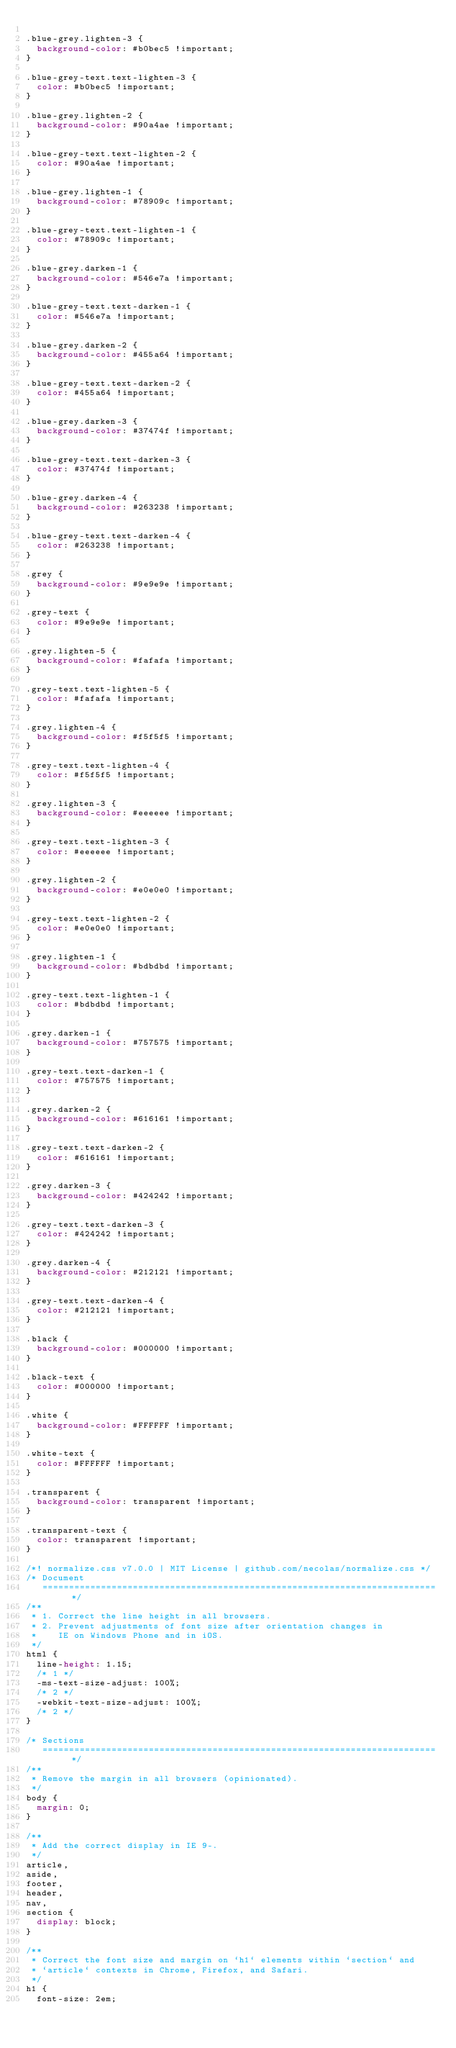<code> <loc_0><loc_0><loc_500><loc_500><_CSS_>
.blue-grey.lighten-3 {
  background-color: #b0bec5 !important;
}

.blue-grey-text.text-lighten-3 {
  color: #b0bec5 !important;
}

.blue-grey.lighten-2 {
  background-color: #90a4ae !important;
}

.blue-grey-text.text-lighten-2 {
  color: #90a4ae !important;
}

.blue-grey.lighten-1 {
  background-color: #78909c !important;
}

.blue-grey-text.text-lighten-1 {
  color: #78909c !important;
}

.blue-grey.darken-1 {
  background-color: #546e7a !important;
}

.blue-grey-text.text-darken-1 {
  color: #546e7a !important;
}

.blue-grey.darken-2 {
  background-color: #455a64 !important;
}

.blue-grey-text.text-darken-2 {
  color: #455a64 !important;
}

.blue-grey.darken-3 {
  background-color: #37474f !important;
}

.blue-grey-text.text-darken-3 {
  color: #37474f !important;
}

.blue-grey.darken-4 {
  background-color: #263238 !important;
}

.blue-grey-text.text-darken-4 {
  color: #263238 !important;
}

.grey {
  background-color: #9e9e9e !important;
}

.grey-text {
  color: #9e9e9e !important;
}

.grey.lighten-5 {
  background-color: #fafafa !important;
}

.grey-text.text-lighten-5 {
  color: #fafafa !important;
}

.grey.lighten-4 {
  background-color: #f5f5f5 !important;
}

.grey-text.text-lighten-4 {
  color: #f5f5f5 !important;
}

.grey.lighten-3 {
  background-color: #eeeeee !important;
}

.grey-text.text-lighten-3 {
  color: #eeeeee !important;
}

.grey.lighten-2 {
  background-color: #e0e0e0 !important;
}

.grey-text.text-lighten-2 {
  color: #e0e0e0 !important;
}

.grey.lighten-1 {
  background-color: #bdbdbd !important;
}

.grey-text.text-lighten-1 {
  color: #bdbdbd !important;
}

.grey.darken-1 {
  background-color: #757575 !important;
}

.grey-text.text-darken-1 {
  color: #757575 !important;
}

.grey.darken-2 {
  background-color: #616161 !important;
}

.grey-text.text-darken-2 {
  color: #616161 !important;
}

.grey.darken-3 {
  background-color: #424242 !important;
}

.grey-text.text-darken-3 {
  color: #424242 !important;
}

.grey.darken-4 {
  background-color: #212121 !important;
}

.grey-text.text-darken-4 {
  color: #212121 !important;
}

.black {
  background-color: #000000 !important;
}

.black-text {
  color: #000000 !important;
}

.white {
  background-color: #FFFFFF !important;
}

.white-text {
  color: #FFFFFF !important;
}

.transparent {
  background-color: transparent !important;
}

.transparent-text {
  color: transparent !important;
}

/*! normalize.css v7.0.0 | MIT License | github.com/necolas/normalize.css */
/* Document
   ========================================================================== */
/**
 * 1. Correct the line height in all browsers.
 * 2. Prevent adjustments of font size after orientation changes in
 *    IE on Windows Phone and in iOS.
 */
html {
  line-height: 1.15;
  /* 1 */
  -ms-text-size-adjust: 100%;
  /* 2 */
  -webkit-text-size-adjust: 100%;
  /* 2 */
}

/* Sections
   ========================================================================== */
/**
 * Remove the margin in all browsers (opinionated).
 */
body {
  margin: 0;
}

/**
 * Add the correct display in IE 9-.
 */
article,
aside,
footer,
header,
nav,
section {
  display: block;
}

/**
 * Correct the font size and margin on `h1` elements within `section` and
 * `article` contexts in Chrome, Firefox, and Safari.
 */
h1 {
  font-size: 2em;</code> 